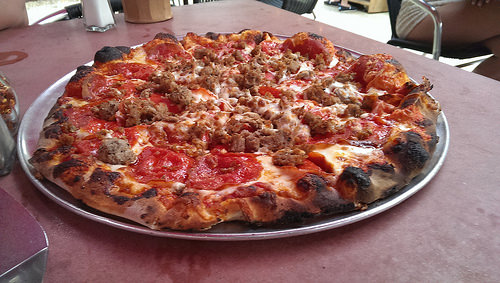<image>
Is there a food on the table? Yes. Looking at the image, I can see the food is positioned on top of the table, with the table providing support. 